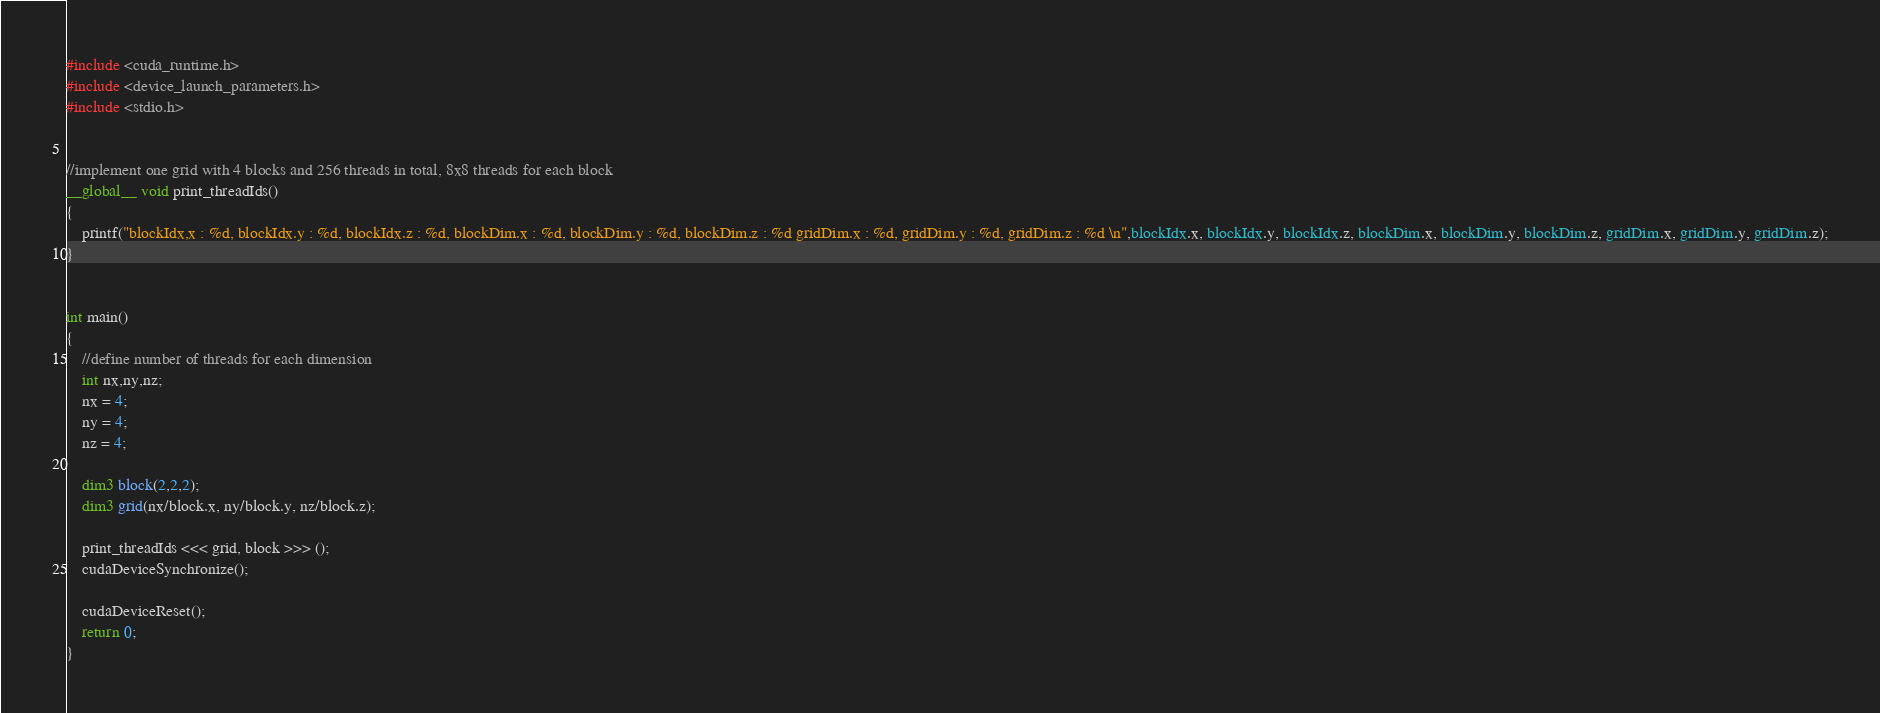Convert code to text. <code><loc_0><loc_0><loc_500><loc_500><_Cuda_>#include <cuda_runtime.h>
#include <device_launch_parameters.h>
#include <stdio.h>


//implement one grid with 4 blocks and 256 threads in total, 8x8 threads for each block
__global__ void print_threadIds()
{
	printf("blockIdx,x : %d, blockIdx.y : %d, blockIdx.z : %d, blockDim.x : %d, blockDim.y : %d, blockDim.z : %d gridDim.x : %d, gridDim.y : %d, gridDim.z : %d \n",blockIdx.x, blockIdx.y, blockIdx.z, blockDim.x, blockDim.y, blockDim.z, gridDim.x, gridDim.y, gridDim.z);
}


int main()
{	
	//define number of threads for each dimension
	int nx,ny,nz;
	nx = 4;
	ny = 4;
	nz = 4;
	
	dim3 block(2,2,2);
	dim3 grid(nx/block.x, ny/block.y, nz/block.z);

	print_threadIds <<< grid, block >>> ();
	cudaDeviceSynchronize();

	cudaDeviceReset();
	return 0;
}
</code> 